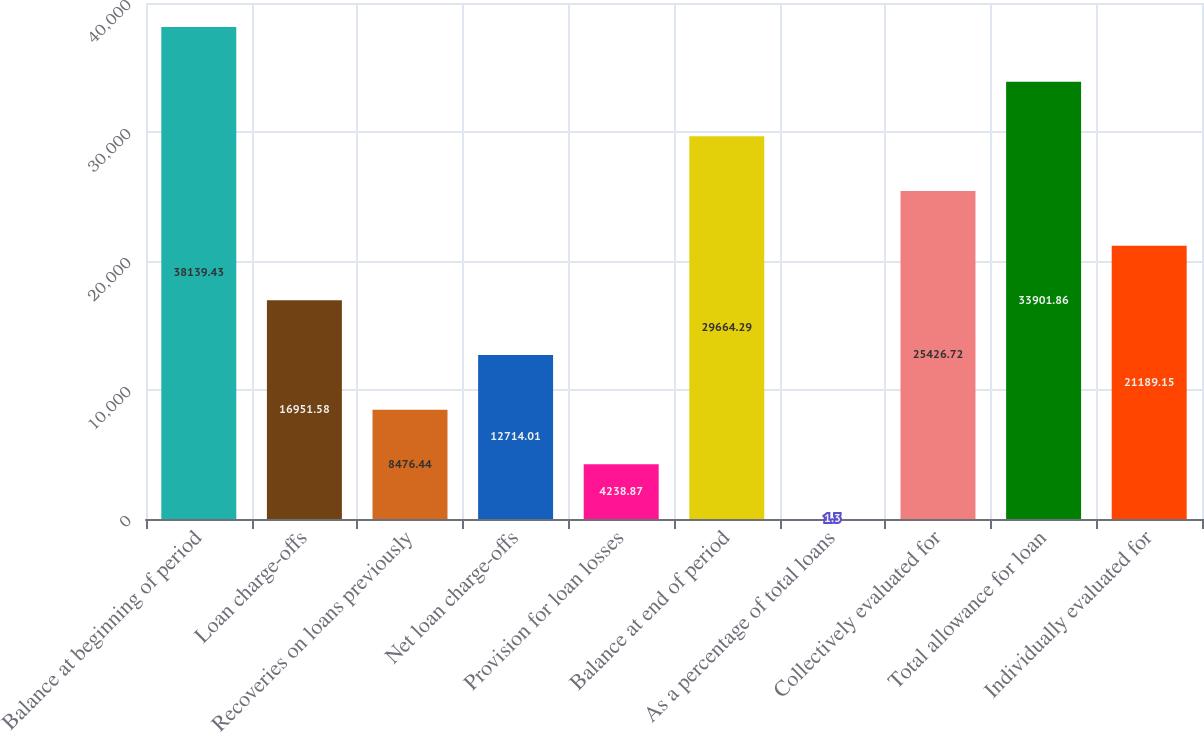Convert chart. <chart><loc_0><loc_0><loc_500><loc_500><bar_chart><fcel>Balance at beginning of period<fcel>Loan charge-offs<fcel>Recoveries on loans previously<fcel>Net loan charge-offs<fcel>Provision for loan losses<fcel>Balance at end of period<fcel>As a percentage of total loans<fcel>Collectively evaluated for<fcel>Total allowance for loan<fcel>Individually evaluated for<nl><fcel>38139.4<fcel>16951.6<fcel>8476.44<fcel>12714<fcel>4238.87<fcel>29664.3<fcel>1.3<fcel>25426.7<fcel>33901.9<fcel>21189.2<nl></chart> 